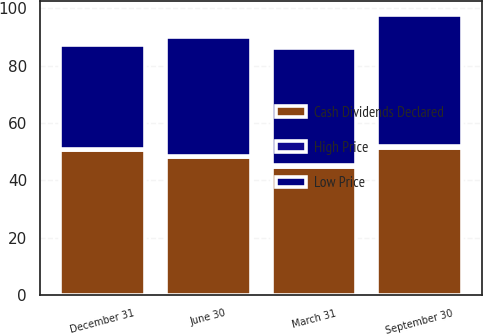Convert chart to OTSL. <chart><loc_0><loc_0><loc_500><loc_500><stacked_bar_chart><ecel><fcel>March 31<fcel>June 30<fcel>September 30<fcel>December 31<nl><fcel>Cash Dividends Declared<fcel>44.78<fcel>47.99<fcel>51.38<fcel>50.4<nl><fcel>Low Price<fcel>40.9<fcel>41.65<fcel>45.81<fcel>36.3<nl><fcel>High Price<fcel>0.46<fcel>0.46<fcel>0.46<fcel>0.46<nl></chart> 